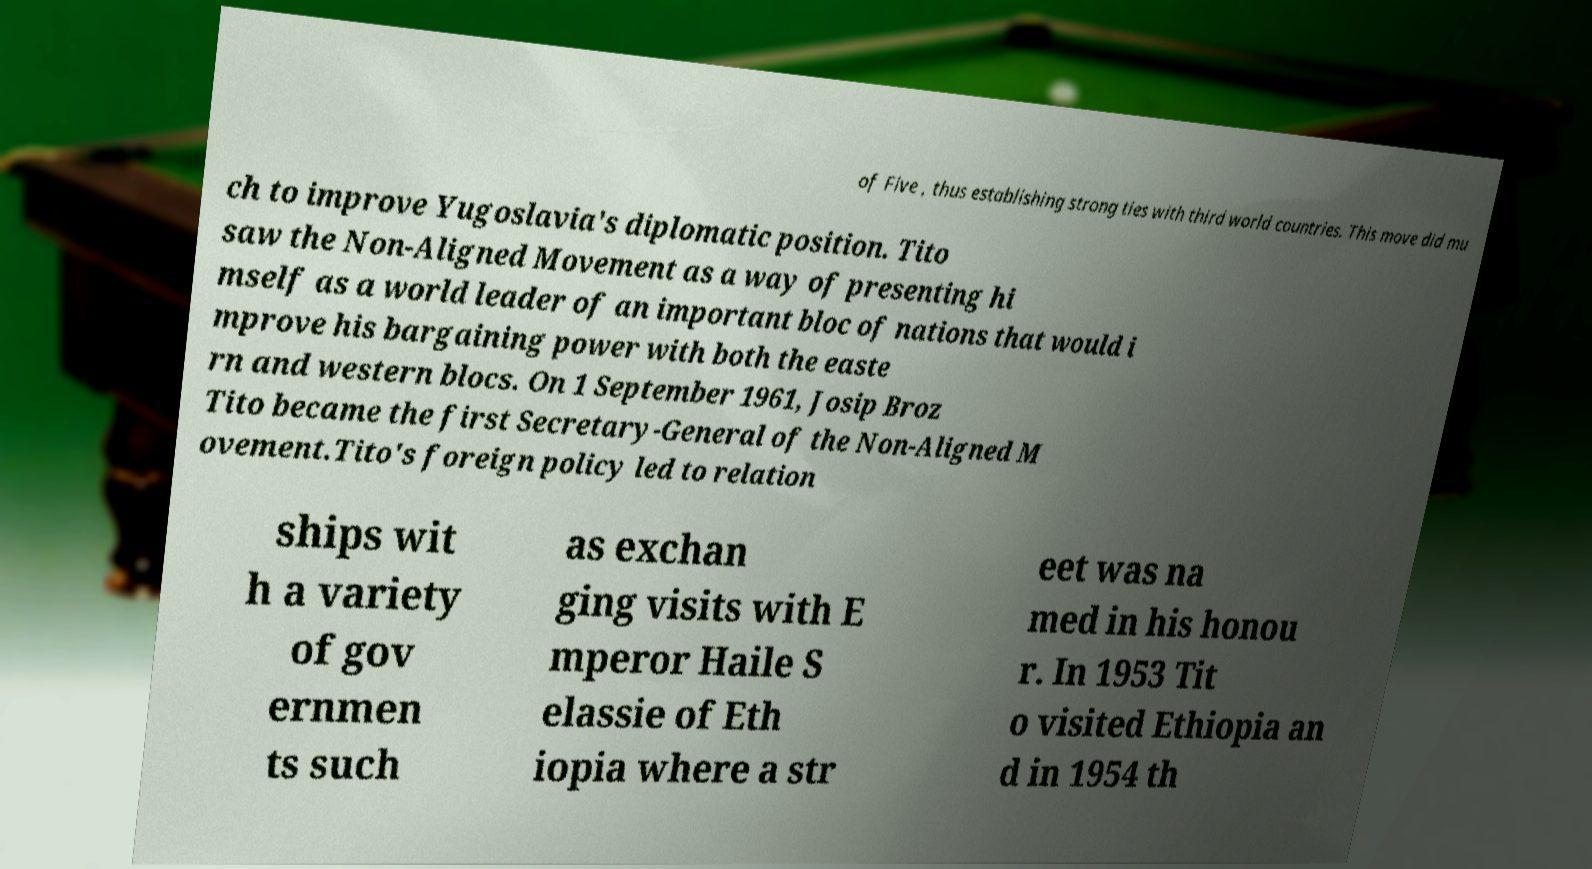What messages or text are displayed in this image? I need them in a readable, typed format. of Five , thus establishing strong ties with third world countries. This move did mu ch to improve Yugoslavia's diplomatic position. Tito saw the Non-Aligned Movement as a way of presenting hi mself as a world leader of an important bloc of nations that would i mprove his bargaining power with both the easte rn and western blocs. On 1 September 1961, Josip Broz Tito became the first Secretary-General of the Non-Aligned M ovement.Tito's foreign policy led to relation ships wit h a variety of gov ernmen ts such as exchan ging visits with E mperor Haile S elassie of Eth iopia where a str eet was na med in his honou r. In 1953 Tit o visited Ethiopia an d in 1954 th 